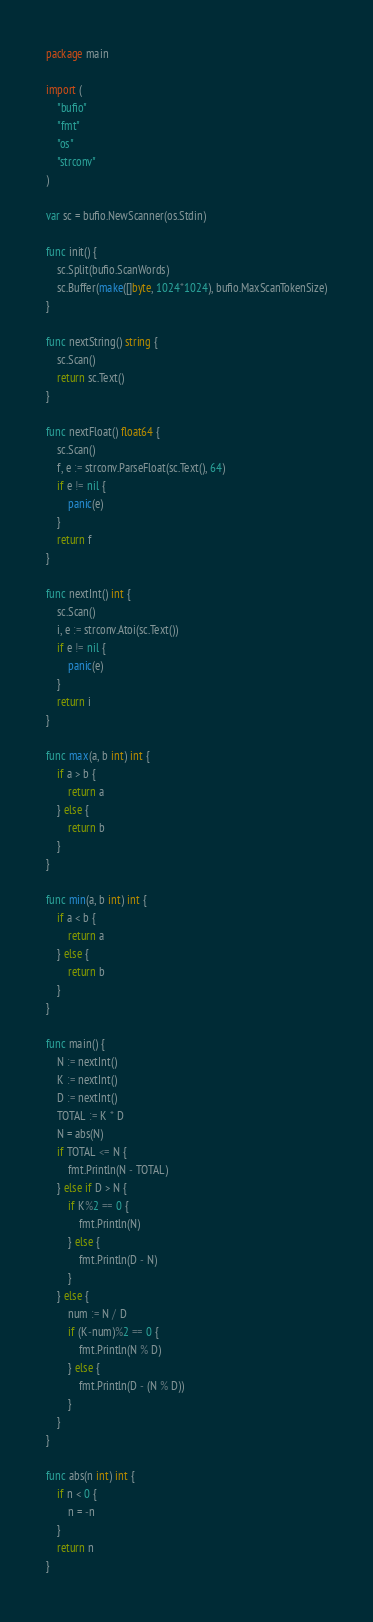Convert code to text. <code><loc_0><loc_0><loc_500><loc_500><_Go_>package main

import (
	"bufio"
	"fmt"
	"os"
	"strconv"
)

var sc = bufio.NewScanner(os.Stdin)

func init() {
	sc.Split(bufio.ScanWords)
	sc.Buffer(make([]byte, 1024*1024), bufio.MaxScanTokenSize)
}

func nextString() string {
	sc.Scan()
	return sc.Text()
}

func nextFloat() float64 {
	sc.Scan()
	f, e := strconv.ParseFloat(sc.Text(), 64)
	if e != nil {
		panic(e)
	}
	return f
}

func nextInt() int {
	sc.Scan()
	i, e := strconv.Atoi(sc.Text())
	if e != nil {
		panic(e)
	}
	return i
}

func max(a, b int) int {
	if a > b {
		return a
	} else {
		return b
	}
}

func min(a, b int) int {
	if a < b {
		return a
	} else {
		return b
	}
}

func main() {
	N := nextInt()
	K := nextInt()
	D := nextInt()
	TOTAL := K * D
	N = abs(N)
	if TOTAL <= N {
		fmt.Println(N - TOTAL)
	} else if D > N {
		if K%2 == 0 {
			fmt.Println(N)
		} else {
			fmt.Println(D - N)
		}
	} else {
		num := N / D
		if (K-num)%2 == 0 {
			fmt.Println(N % D)
		} else {
			fmt.Println(D - (N % D))
		}
	}
}

func abs(n int) int {
	if n < 0 {
		n = -n
	}
	return n
}
</code> 